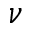Convert formula to latex. <formula><loc_0><loc_0><loc_500><loc_500>{ \nu }</formula> 